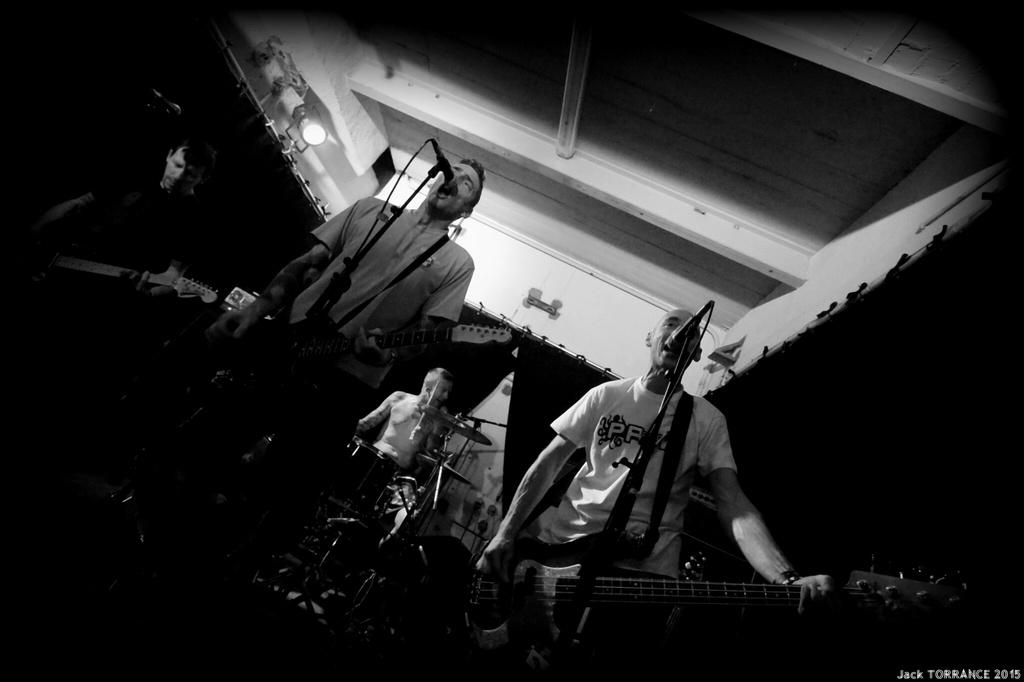How many people are in the image? There are four people in the image. What are the people in the image doing? All four people are musicians, and they are playing musical instruments. What can be seen in front of the musicians? They are playing in front of a microphone. What is visible in the background of the image? There are curtains and lights in the background of the image. Can you see any crows flying in the image? There are no crows visible in the image. Are there any mice hiding behind the curtains in the image? There is no mention of mice in the image, and it is not possible to determine their presence based on the provided facts. 